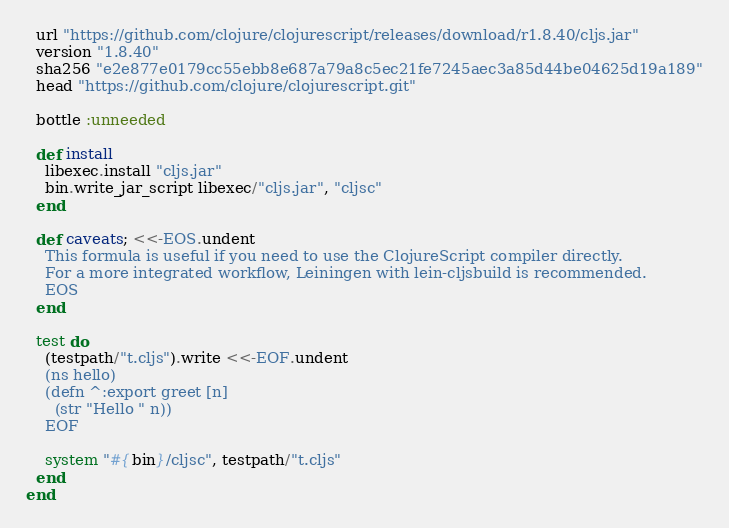Convert code to text. <code><loc_0><loc_0><loc_500><loc_500><_Ruby_>  url "https://github.com/clojure/clojurescript/releases/download/r1.8.40/cljs.jar"
  version "1.8.40"
  sha256 "e2e877e0179cc55ebb8e687a79a8c5ec21fe7245aec3a85d44be04625d19a189"
  head "https://github.com/clojure/clojurescript.git"

  bottle :unneeded

  def install
    libexec.install "cljs.jar"
    bin.write_jar_script libexec/"cljs.jar", "cljsc"
  end

  def caveats; <<-EOS.undent
    This formula is useful if you need to use the ClojureScript compiler directly.
    For a more integrated workflow, Leiningen with lein-cljsbuild is recommended.
    EOS
  end

  test do
    (testpath/"t.cljs").write <<-EOF.undent
    (ns hello)
    (defn ^:export greet [n]
      (str "Hello " n))
    EOF

    system "#{bin}/cljsc", testpath/"t.cljs"
  end
end
</code> 